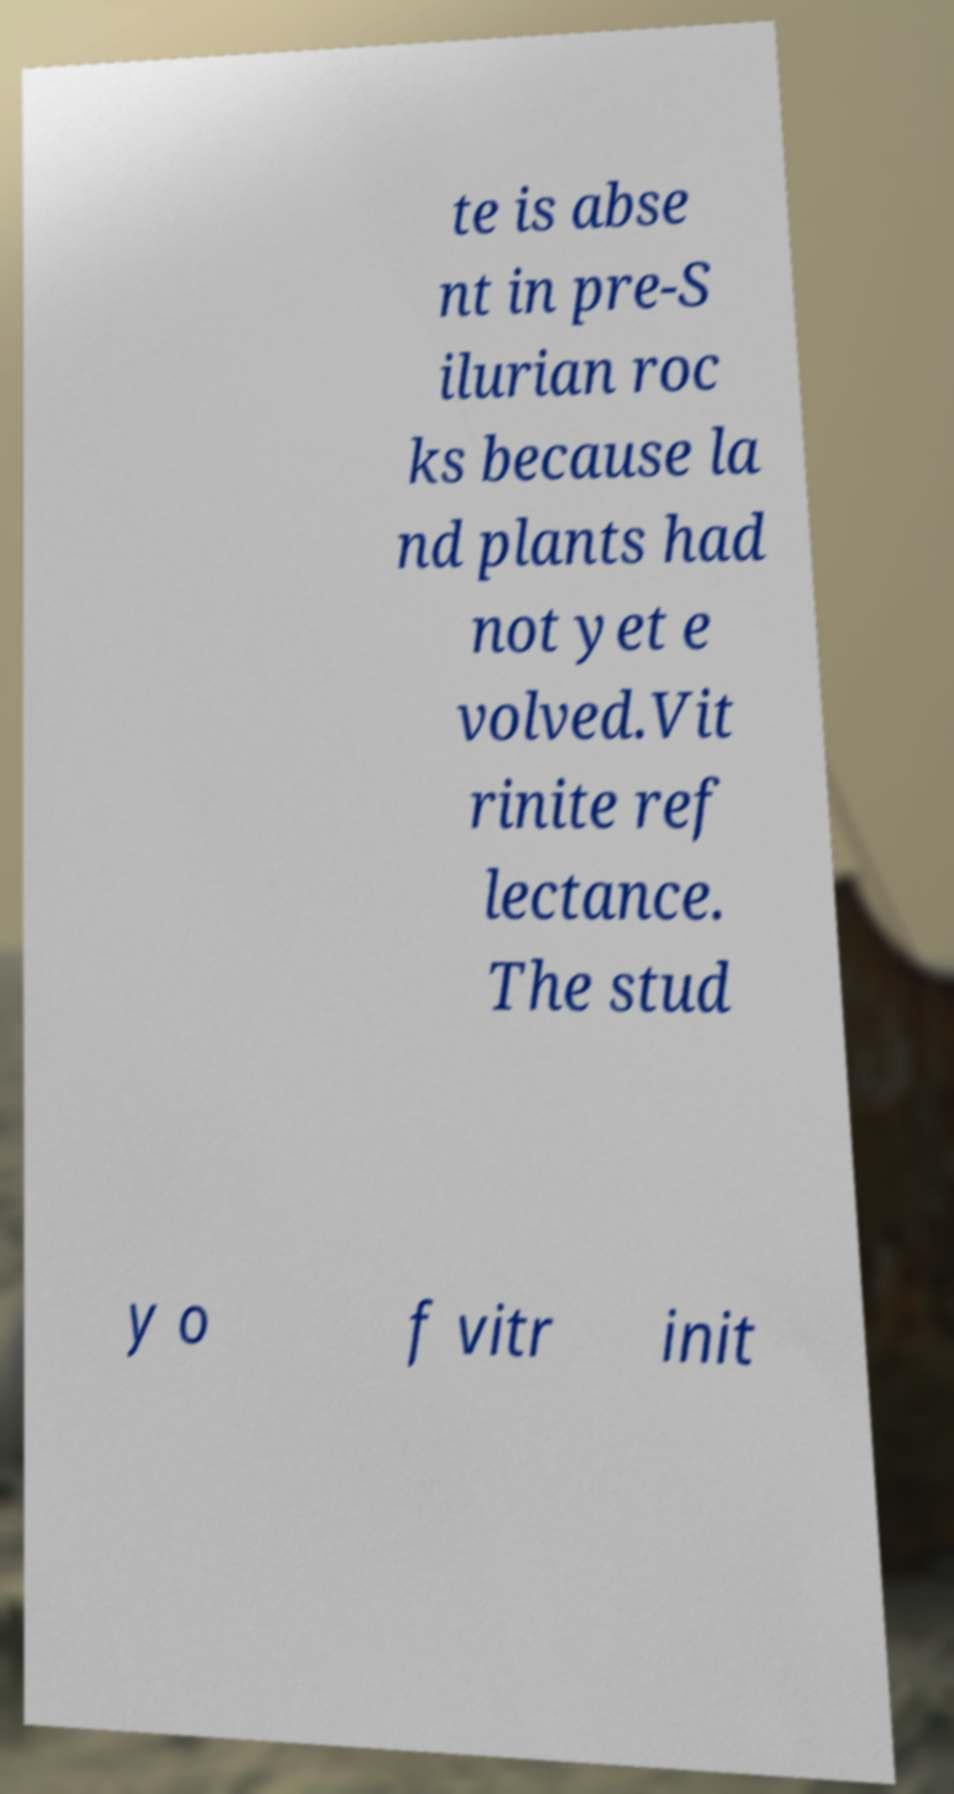What messages or text are displayed in this image? I need them in a readable, typed format. te is abse nt in pre-S ilurian roc ks because la nd plants had not yet e volved.Vit rinite ref lectance. The stud y o f vitr init 